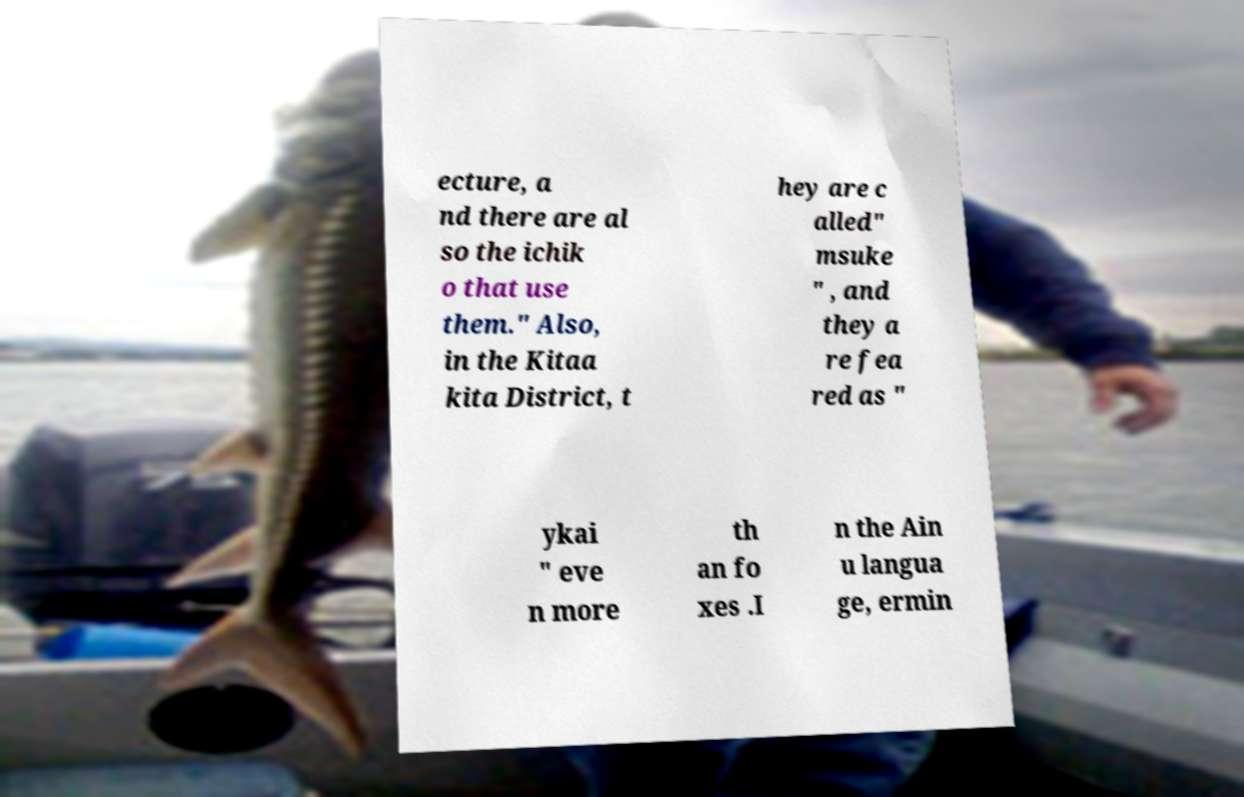For documentation purposes, I need the text within this image transcribed. Could you provide that? ecture, a nd there are al so the ichik o that use them." Also, in the Kitaa kita District, t hey are c alled" msuke " , and they a re fea red as " ykai " eve n more th an fo xes .I n the Ain u langua ge, ermin 